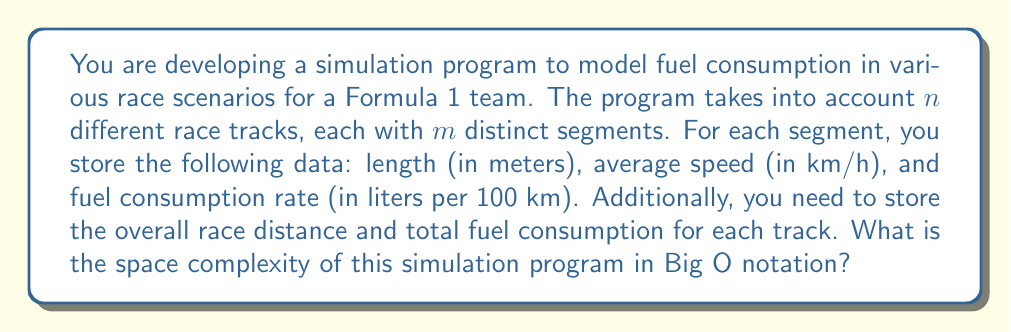Teach me how to tackle this problem. To determine the space complexity, let's break down the data storage requirements:

1. For each track segment:
   - Length: 1 float
   - Average speed: 1 float
   - Fuel consumption rate: 1 float
   Total per segment: 3 floats

2. Number of segments per track: $m$

3. Data for all segments in one track: $3m$ floats

4. Additional data per track:
   - Overall race distance: 1 float
   - Total fuel consumption: 1 float
   Total additional data per track: 2 floats

5. Total data per track: $3m + 2$ floats

6. Number of tracks: $n$

7. Total data for all tracks: $n(3m + 2)$ floats

The space complexity is determined by the amount of memory required to store this data. Since we have a total of $n(3m + 2)$ floats, and the space required for each float is constant, we can express the space complexity as:

$$O(nm)$$

This is because the dominant term in $n(3m + 2)$ is $nm$, and we drop constants and lower-order terms in Big O notation.

Note that this space complexity assumes that $n$ and $m$ are variables that can grow independently. If one were fixed, the complexity would be linear in terms of the other variable.
Answer: $O(nm)$ 